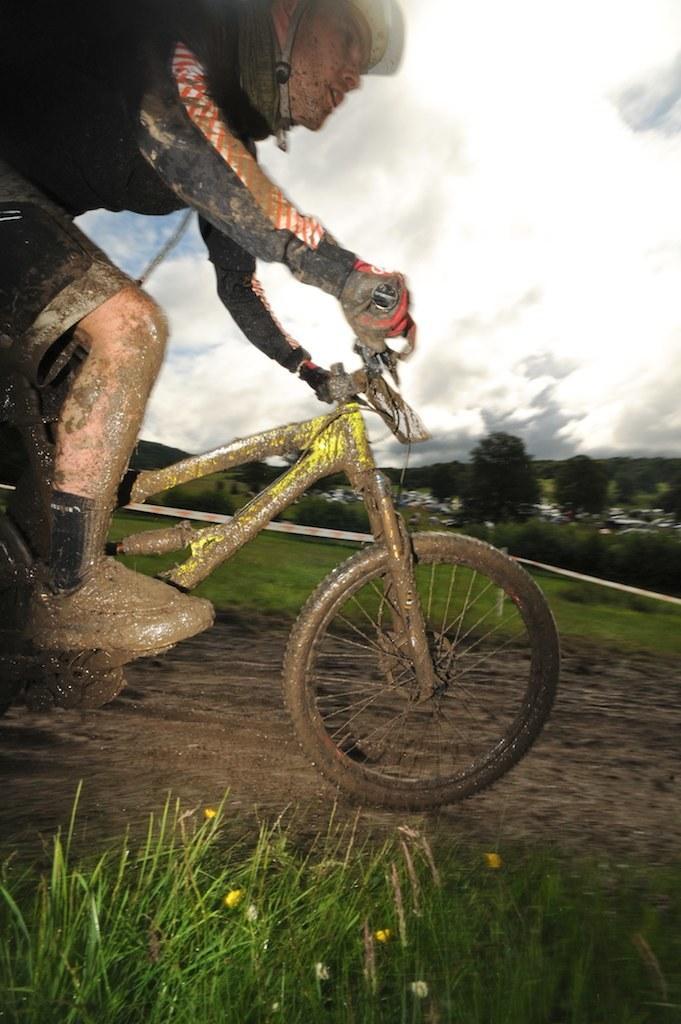Could you give a brief overview of what you see in this image? In this image I see a man who is on a cycle and he is riding on the mud, I can also see grass over here. In the background I see the trees and the sky. I can also see he is wearing a helmet. 